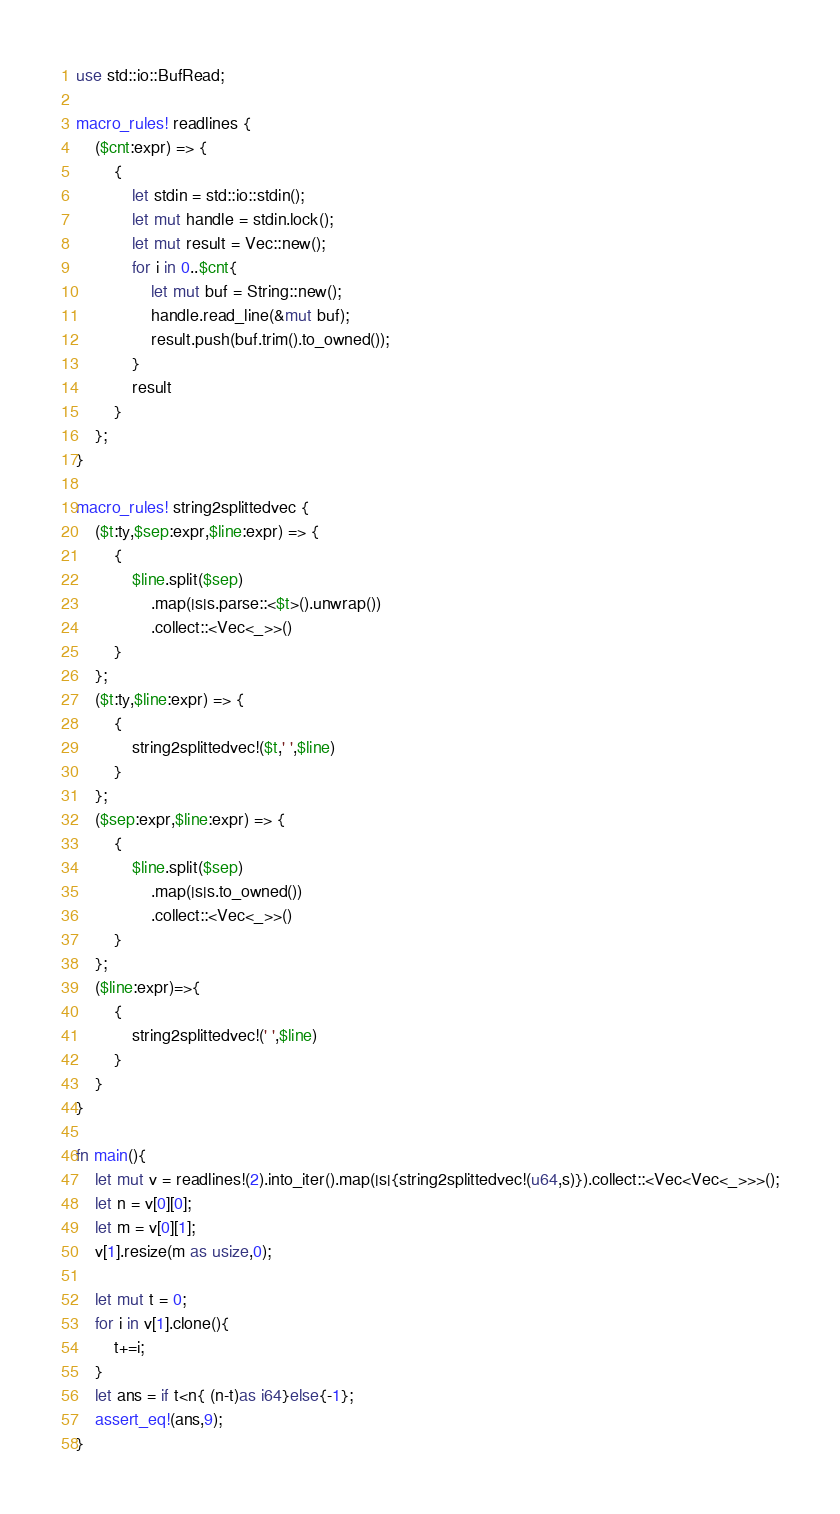Convert code to text. <code><loc_0><loc_0><loc_500><loc_500><_Rust_>use std::io::BufRead;

macro_rules! readlines {
    ($cnt:expr) => {
        {
            let stdin = std::io::stdin();
            let mut handle = stdin.lock();
            let mut result = Vec::new();
            for i in 0..$cnt{
                let mut buf = String::new();
                handle.read_line(&mut buf);
                result.push(buf.trim().to_owned());
            }
            result
        }
    };
}

macro_rules! string2splittedvec {
    ($t:ty,$sep:expr,$line:expr) => {
        {
            $line.split($sep)
                .map(|s|s.parse::<$t>().unwrap())
                .collect::<Vec<_>>()
        }
    };
    ($t:ty,$line:expr) => {
        {
            string2splittedvec!($t,' ',$line)
        }
    };
    ($sep:expr,$line:expr) => {
        {
            $line.split($sep)
                .map(|s|s.to_owned())
                .collect::<Vec<_>>()
        }
    };
    ($line:expr)=>{
        {
            string2splittedvec!(' ',$line)
        }
    }
}

fn main(){
    let mut v = readlines!(2).into_iter().map(|s|{string2splittedvec!(u64,s)}).collect::<Vec<Vec<_>>>();
    let n = v[0][0];
    let m = v[0][1];
    v[1].resize(m as usize,0);
    
    let mut t = 0;
    for i in v[1].clone(){
        t+=i;
    }
    let ans = if t<n{ (n-t)as i64}else{-1};
    assert_eq!(ans,9);
}
</code> 